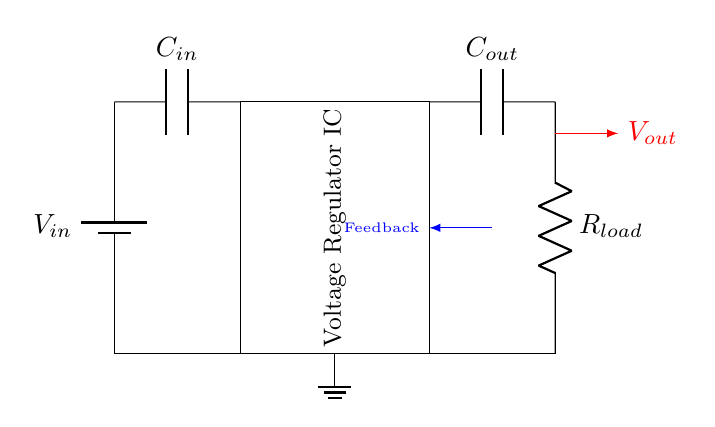What is the input voltage source labeled as? The input voltage source is labeled as V in, which represents the voltage supplied to the circuit.
Answer: V in What type of component is the large rectangle labeled in the circuit? The large rectangle represents a voltage regulator IC, an integrated circuit designed to maintain a stable output voltage regardless of variations in input voltage or load current.
Answer: Voltage Regulator IC How many capacitors are in the circuit? There are two capacitors indicated in the circuit, one labeled as C in and the other as C out.
Answer: Two What is the function of the feedback line in this circuit? The feedback line, labeled in blue, connects the output of the voltage regulator back to itself to provide regulation. It ensures that changes in output voltage are monitored to maintain a stable output.
Answer: Regulation Which component directly connects the output voltage to the load? The load resistor, labeled as R load, is the component that directly connects to the output voltage (V out) and consumes power from the regulated output.
Answer: R load 